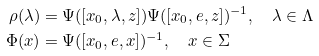<formula> <loc_0><loc_0><loc_500><loc_500>\rho ( \lambda ) & = \Psi ( [ x _ { 0 } , \lambda , z ] ) \Psi ( [ x _ { 0 } , e , z ] ) ^ { - 1 } , \quad \lambda \in \Lambda \\ \Phi ( x ) & = \Psi ( [ x _ { 0 } , e , x ] ) ^ { - 1 } , \quad x \in \Sigma</formula> 